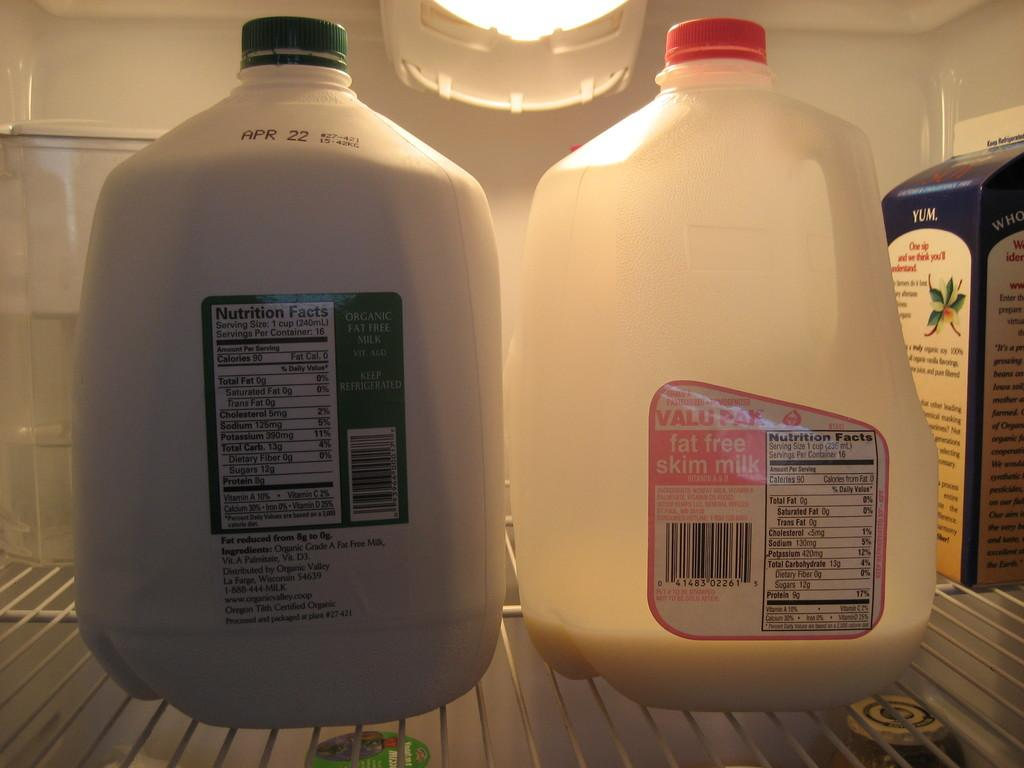What objects are present in the image that are white in color? There are two white bottles in the image. What type of container is present in the image? There is a cardboard box in the image. What can be seen in the background of the image? The background of the image includes light. What type of bread is visible in the image? There is no bread present in the image. What kind of bait is being used in the image? There is no bait present in the image. 